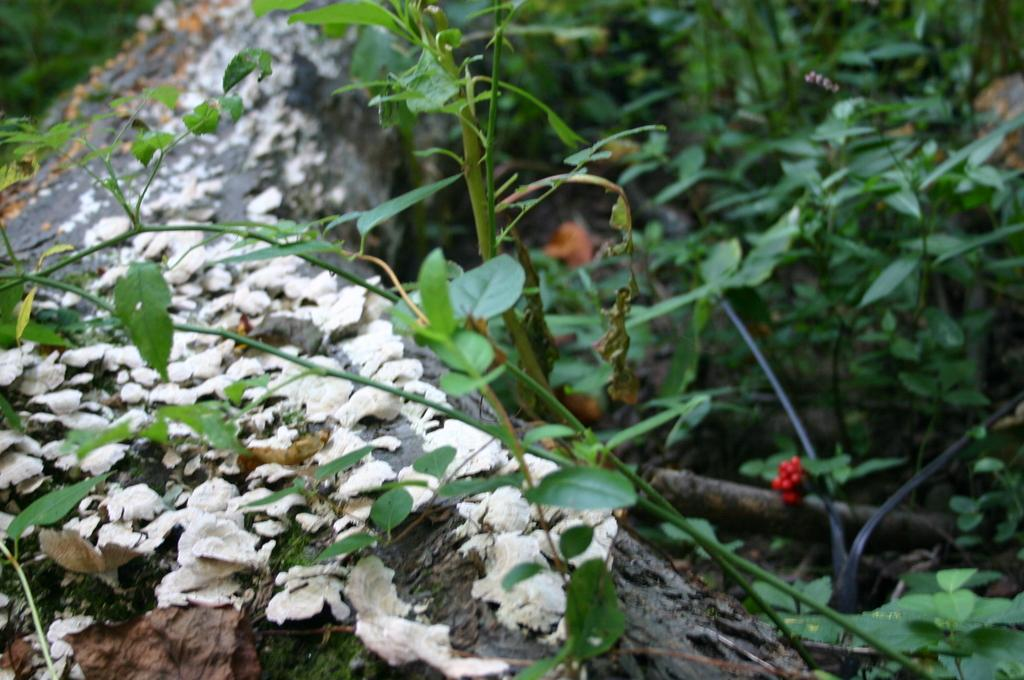What type of living organisms are present in the image? The image contains plants. What can be seen on the left side of the image? There are dried leaves on the left side of the image. What structure is visible in the front of the image? There appears to be a wall in the front of the image. What type of card is the man holding on the day depicted in the image? There is no man or card present in the image, and the day is not mentioned in the provided facts. 